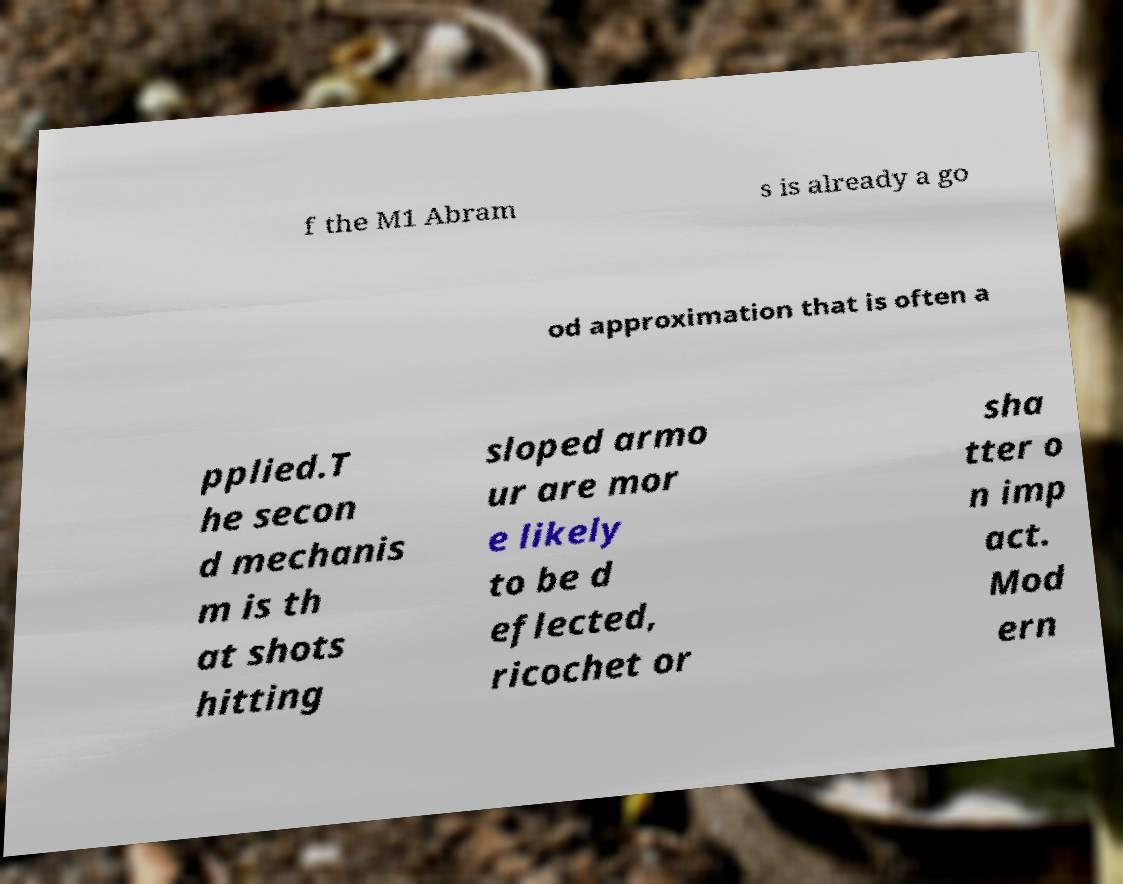For documentation purposes, I need the text within this image transcribed. Could you provide that? f the M1 Abram s is already a go od approximation that is often a pplied.T he secon d mechanis m is th at shots hitting sloped armo ur are mor e likely to be d eflected, ricochet or sha tter o n imp act. Mod ern 